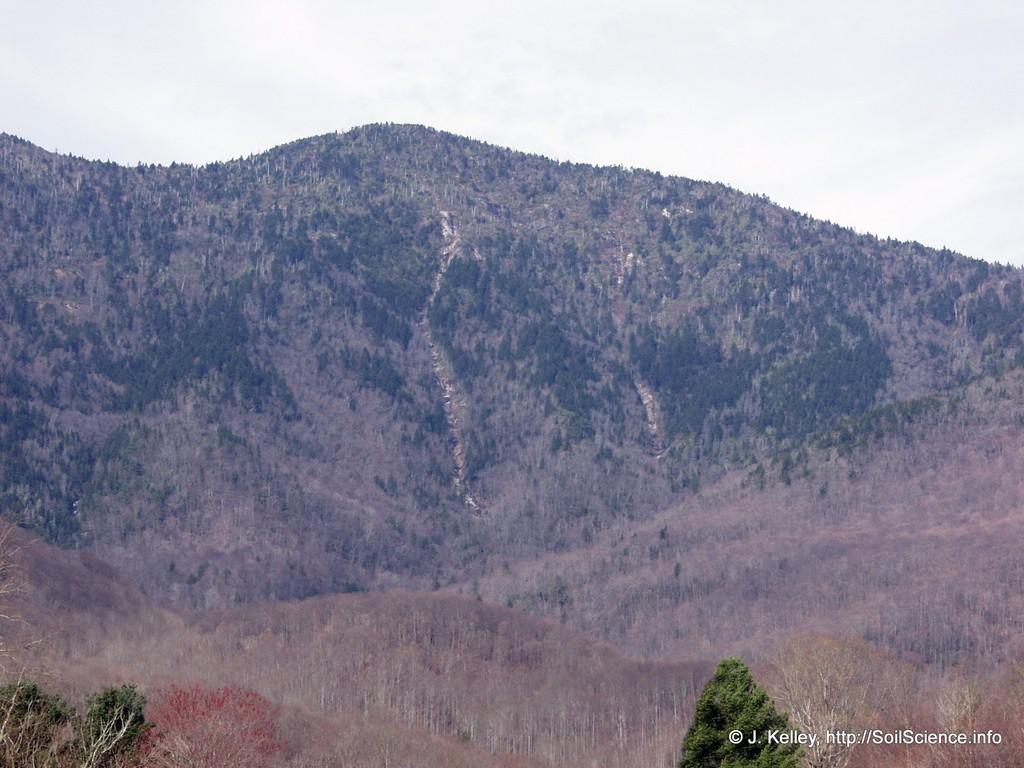Please provide a concise description of this image. In this picture we can see trees, mountains and in the background we can see the sky. 